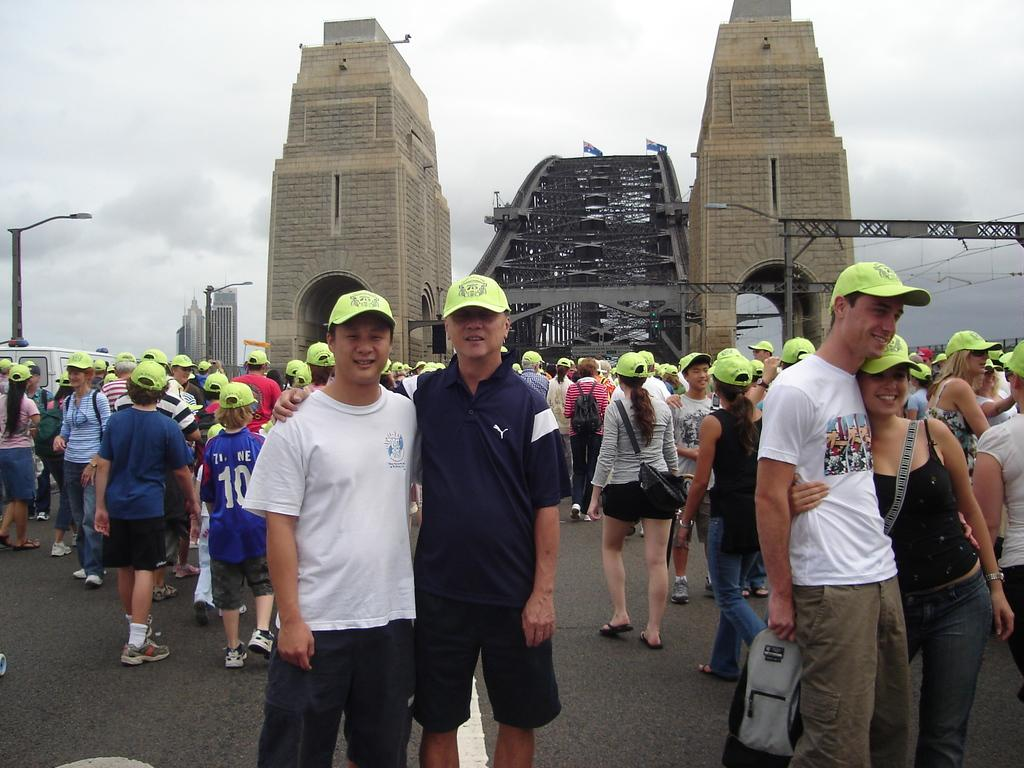What are the people in the image doing? There is a group of people standing on a path in the image, and some people are walking. What can be seen in the background of the image? There are light poles, a bridge, buildings, walls, and a cloudy sky in the background of the image. What type of jelly can be seen on the bridge in the image? There is no jelly present in the image, and the bridge is not mentioned as having any jelly on it. 